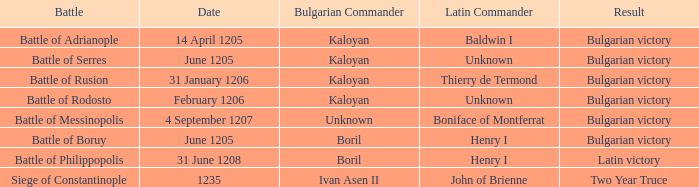What is the skirmish featuring bulgarian commander ivan asen ii? Siege of Constantinople. 